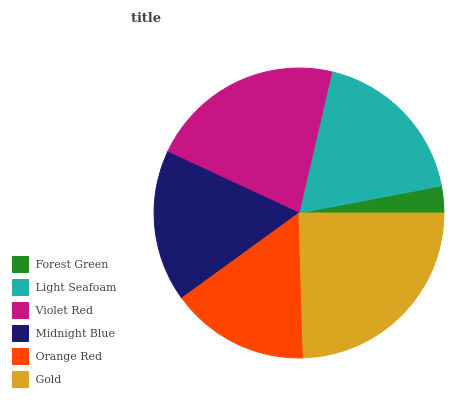Is Forest Green the minimum?
Answer yes or no. Yes. Is Gold the maximum?
Answer yes or no. Yes. Is Light Seafoam the minimum?
Answer yes or no. No. Is Light Seafoam the maximum?
Answer yes or no. No. Is Light Seafoam greater than Forest Green?
Answer yes or no. Yes. Is Forest Green less than Light Seafoam?
Answer yes or no. Yes. Is Forest Green greater than Light Seafoam?
Answer yes or no. No. Is Light Seafoam less than Forest Green?
Answer yes or no. No. Is Light Seafoam the high median?
Answer yes or no. Yes. Is Midnight Blue the low median?
Answer yes or no. Yes. Is Gold the high median?
Answer yes or no. No. Is Violet Red the low median?
Answer yes or no. No. 